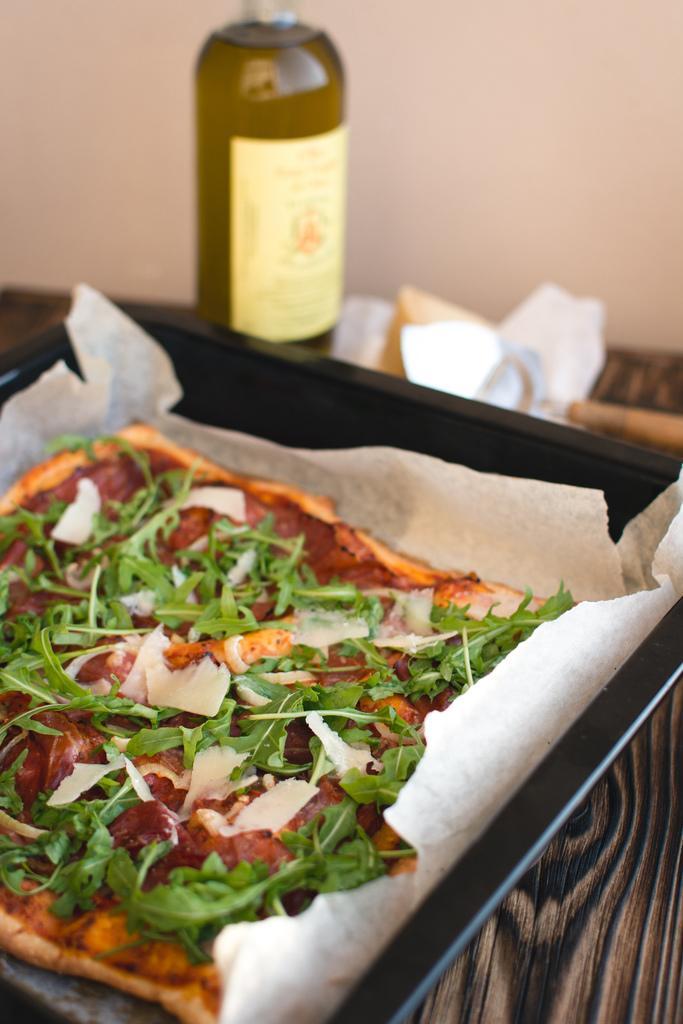In one or two sentences, can you explain what this image depicts? In the center we can see some food item on the table. And beside the plate we can see one bottle. 